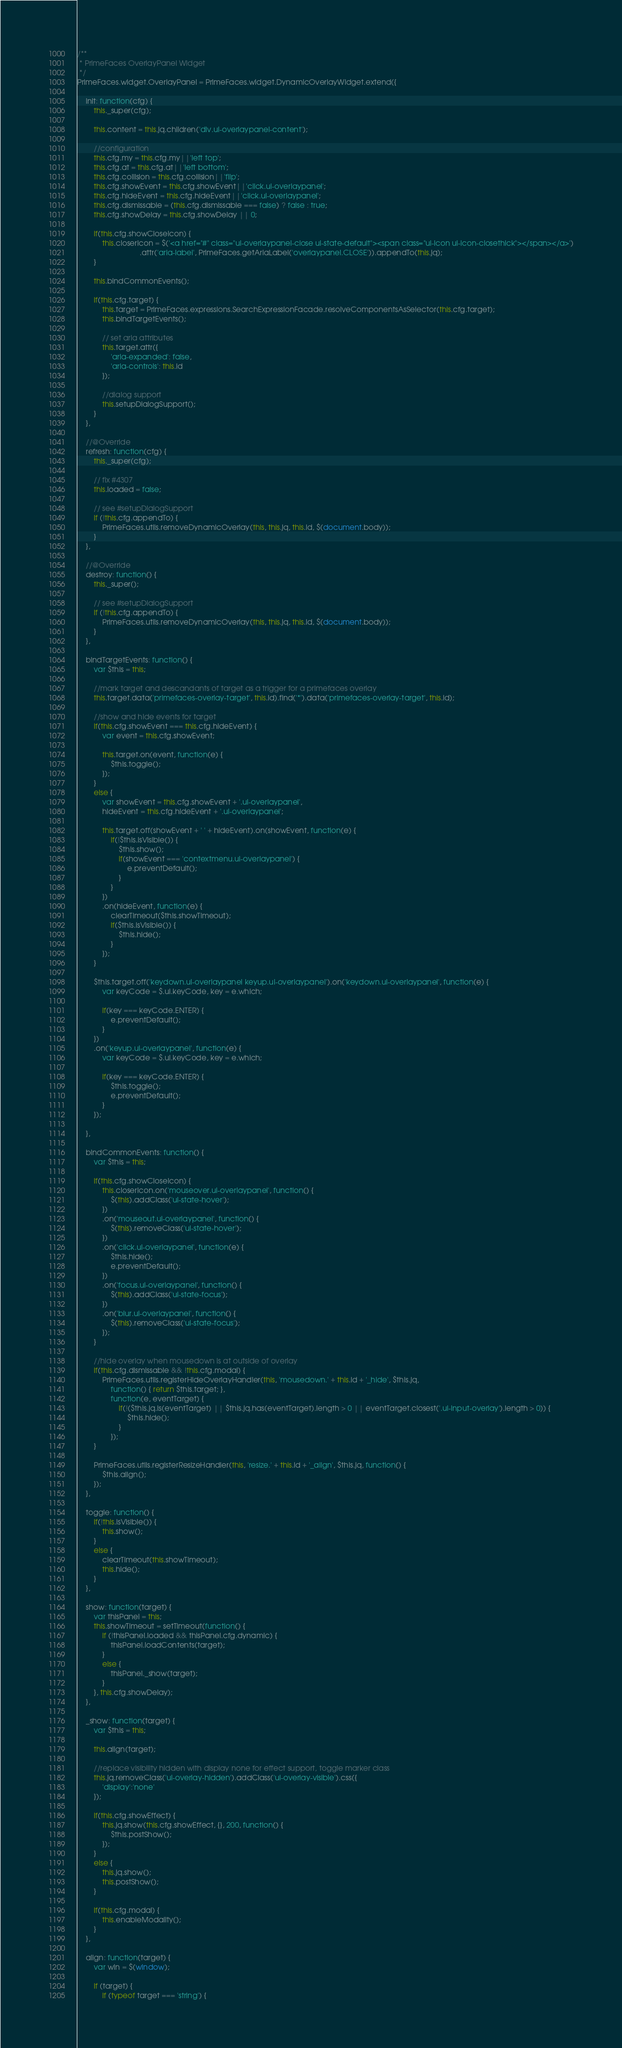Convert code to text. <code><loc_0><loc_0><loc_500><loc_500><_JavaScript_>/**
 * PrimeFaces OverlayPanel Widget
 */
PrimeFaces.widget.OverlayPanel = PrimeFaces.widget.DynamicOverlayWidget.extend({

    init: function(cfg) {
        this._super(cfg);

        this.content = this.jq.children('div.ui-overlaypanel-content');

        //configuration
        this.cfg.my = this.cfg.my||'left top';
        this.cfg.at = this.cfg.at||'left bottom';
        this.cfg.collision = this.cfg.collision||'flip';
        this.cfg.showEvent = this.cfg.showEvent||'click.ui-overlaypanel';
        this.cfg.hideEvent = this.cfg.hideEvent||'click.ui-overlaypanel';
        this.cfg.dismissable = (this.cfg.dismissable === false) ? false : true;
        this.cfg.showDelay = this.cfg.showDelay || 0;

        if(this.cfg.showCloseIcon) {
            this.closerIcon = $('<a href="#" class="ui-overlaypanel-close ui-state-default"><span class="ui-icon ui-icon-closethick"></span></a>')
                              .attr('aria-label', PrimeFaces.getAriaLabel('overlaypanel.CLOSE')).appendTo(this.jq);
        }

        this.bindCommonEvents();

        if(this.cfg.target) {
            this.target = PrimeFaces.expressions.SearchExpressionFacade.resolveComponentsAsSelector(this.cfg.target);
            this.bindTargetEvents();

            // set aria attributes
            this.target.attr({
                'aria-expanded': false,
                'aria-controls': this.id
            });

            //dialog support
            this.setupDialogSupport();
        }
    },

    //@Override
    refresh: function(cfg) {
        this._super(cfg);

        // fix #4307
        this.loaded = false;

        // see #setupDialogSupport
        if (!this.cfg.appendTo) {
            PrimeFaces.utils.removeDynamicOverlay(this, this.jq, this.id, $(document.body));
        }
    },

    //@Override
    destroy: function() {
        this._super();

        // see #setupDialogSupport
        if (!this.cfg.appendTo) {
            PrimeFaces.utils.removeDynamicOverlay(this, this.jq, this.id, $(document.body));
        }
    },

    bindTargetEvents: function() {
        var $this = this;

        //mark target and descandants of target as a trigger for a primefaces overlay
        this.target.data('primefaces-overlay-target', this.id).find('*').data('primefaces-overlay-target', this.id);

        //show and hide events for target
        if(this.cfg.showEvent === this.cfg.hideEvent) {
            var event = this.cfg.showEvent;

            this.target.on(event, function(e) {
                $this.toggle();
            });
        }
        else {
            var showEvent = this.cfg.showEvent + '.ui-overlaypanel',
            hideEvent = this.cfg.hideEvent + '.ui-overlaypanel';

            this.target.off(showEvent + ' ' + hideEvent).on(showEvent, function(e) {
                if(!$this.isVisible()) {
                    $this.show();
                    if(showEvent === 'contextmenu.ui-overlaypanel') {
                        e.preventDefault();
                    }
                }
            })
            .on(hideEvent, function(e) {
            	clearTimeout($this.showTimeout);
                if($this.isVisible()) {
                    $this.hide();
                }
            });
        }

        $this.target.off('keydown.ui-overlaypanel keyup.ui-overlaypanel').on('keydown.ui-overlaypanel', function(e) {
            var keyCode = $.ui.keyCode, key = e.which;

            if(key === keyCode.ENTER) {
                e.preventDefault();
            }
        })
        .on('keyup.ui-overlaypanel', function(e) {
            var keyCode = $.ui.keyCode, key = e.which;

            if(key === keyCode.ENTER) {
                $this.toggle();
                e.preventDefault();
            }
        });

    },

    bindCommonEvents: function() {
        var $this = this;

        if(this.cfg.showCloseIcon) {
            this.closerIcon.on('mouseover.ui-overlaypanel', function() {
                $(this).addClass('ui-state-hover');
            })
            .on('mouseout.ui-overlaypanel', function() {
                $(this).removeClass('ui-state-hover');
            })
            .on('click.ui-overlaypanel', function(e) {
                $this.hide();
                e.preventDefault();
            })
            .on('focus.ui-overlaypanel', function() {
                $(this).addClass('ui-state-focus');
            })
            .on('blur.ui-overlaypanel', function() {
                $(this).removeClass('ui-state-focus');
            });
        }

        //hide overlay when mousedown is at outside of overlay
        if(this.cfg.dismissable && !this.cfg.modal) {
            PrimeFaces.utils.registerHideOverlayHandler(this, 'mousedown.' + this.id + '_hide', $this.jq,
                function() { return $this.target; },
                function(e, eventTarget) {
                    if(!($this.jq.is(eventTarget) || $this.jq.has(eventTarget).length > 0 || eventTarget.closest('.ui-input-overlay').length > 0)) {
                        $this.hide();
                    }
                });
        }

        PrimeFaces.utils.registerResizeHandler(this, 'resize.' + this.id + '_align', $this.jq, function() {
            $this.align();
        });
    },

    toggle: function() {
        if(!this.isVisible()) {
            this.show();
        }
        else {
            clearTimeout(this.showTimeout);
            this.hide();
        }
    },

    show: function(target) {
    	var thisPanel = this;
        this.showTimeout = setTimeout(function() {
            if (!thisPanel.loaded && thisPanel.cfg.dynamic) {
                thisPanel.loadContents(target);
            }
            else {
                thisPanel._show(target);
            }
        }, this.cfg.showDelay);
    },

    _show: function(target) {
        var $this = this;

        this.align(target);

        //replace visibility hidden with display none for effect support, toggle marker class
        this.jq.removeClass('ui-overlay-hidden').addClass('ui-overlay-visible').css({
            'display':'none'
        });

        if(this.cfg.showEffect) {
            this.jq.show(this.cfg.showEffect, {}, 200, function() {
                $this.postShow();
            });
        }
        else {
            this.jq.show();
            this.postShow();
        }

        if(this.cfg.modal) {
            this.enableModality();
        }
    },

    align: function(target) {
        var win = $(window);

        if (target) {
            if (typeof target === 'string') {</code> 